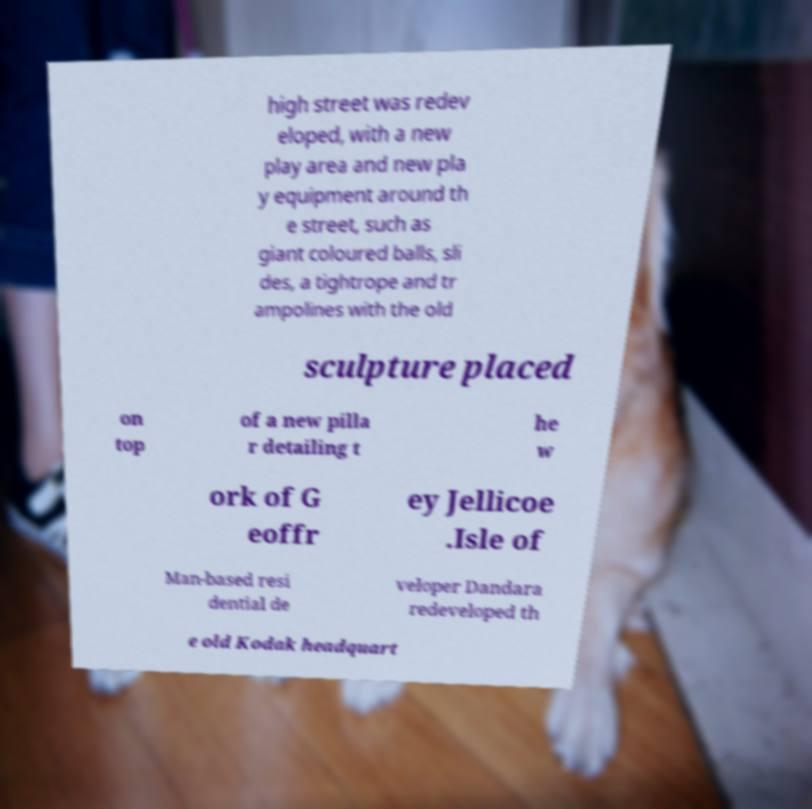Please read and relay the text visible in this image. What does it say? high street was redev eloped, with a new play area and new pla y equipment around th e street, such as giant coloured balls, sli des, a tightrope and tr ampolines with the old sculpture placed on top of a new pilla r detailing t he w ork of G eoffr ey Jellicoe .Isle of Man-based resi dential de veloper Dandara redeveloped th e old Kodak headquart 